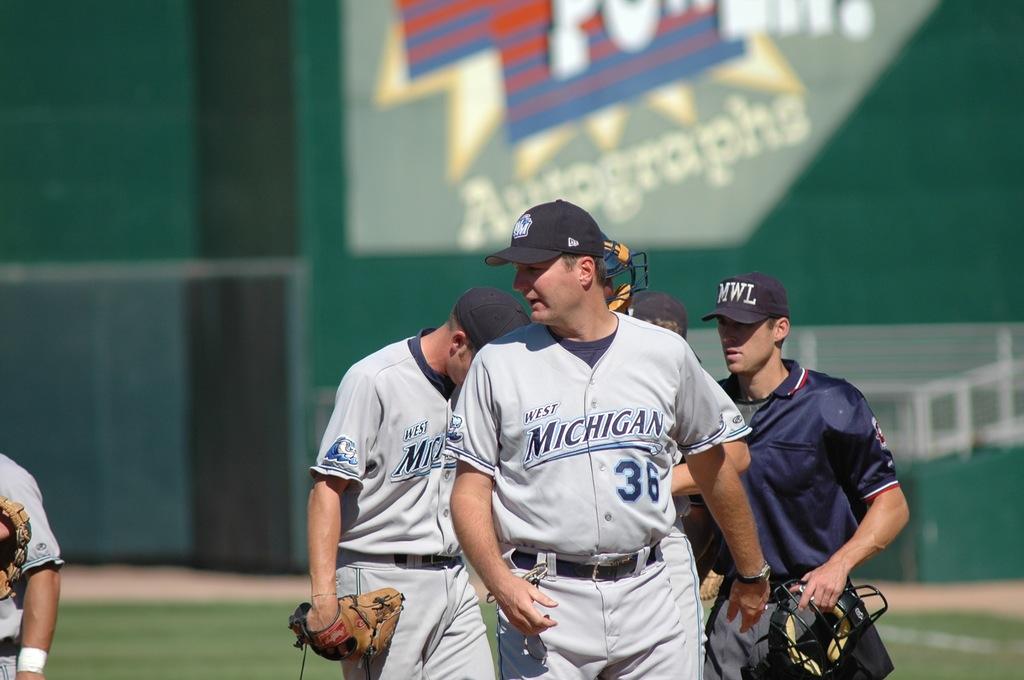Which team is this?
Give a very brief answer. West michigan. What number is on the frontmost players jersey?
Keep it short and to the point. 36. 